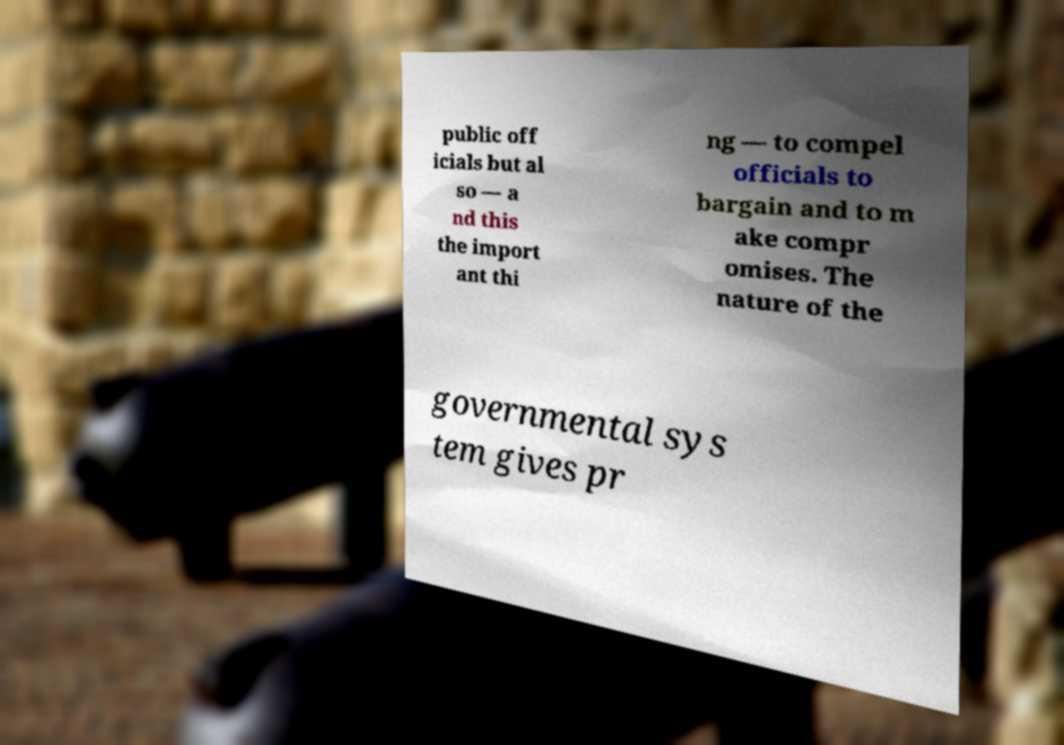There's text embedded in this image that I need extracted. Can you transcribe it verbatim? public off icials but al so — a nd this the import ant thi ng — to compel officials to bargain and to m ake compr omises. The nature of the governmental sys tem gives pr 